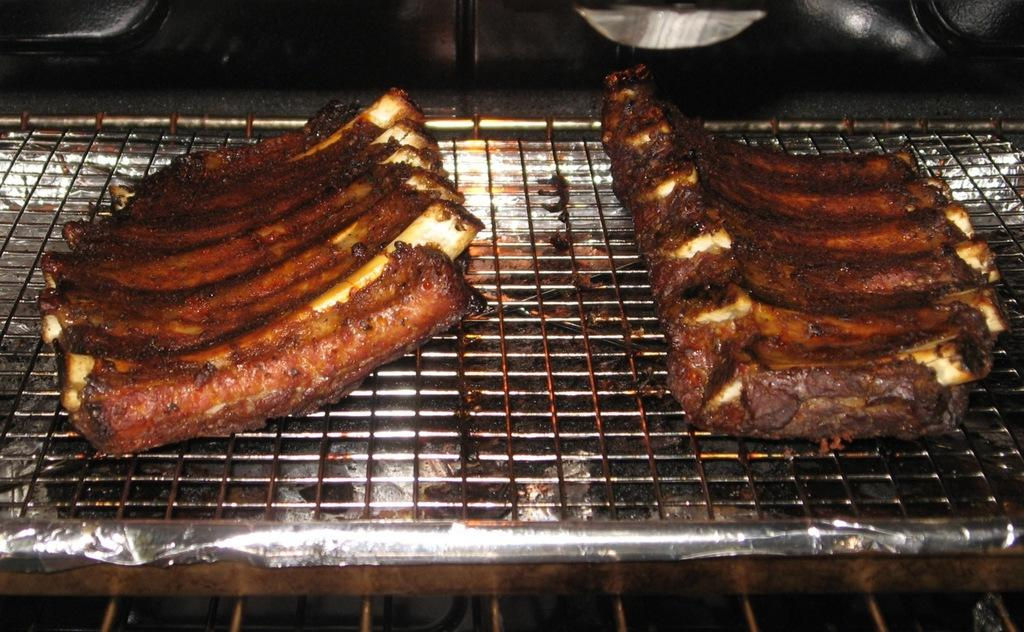What can be seen in the image related to food? There are food items in the image. Where are the food items located? The food items are on a grill. What type of spark can be seen coming from the food items on the grill? There is no spark visible in the image; the food items are simply on the grill. What type of pear is present in the image? There is no pear present in the image. 